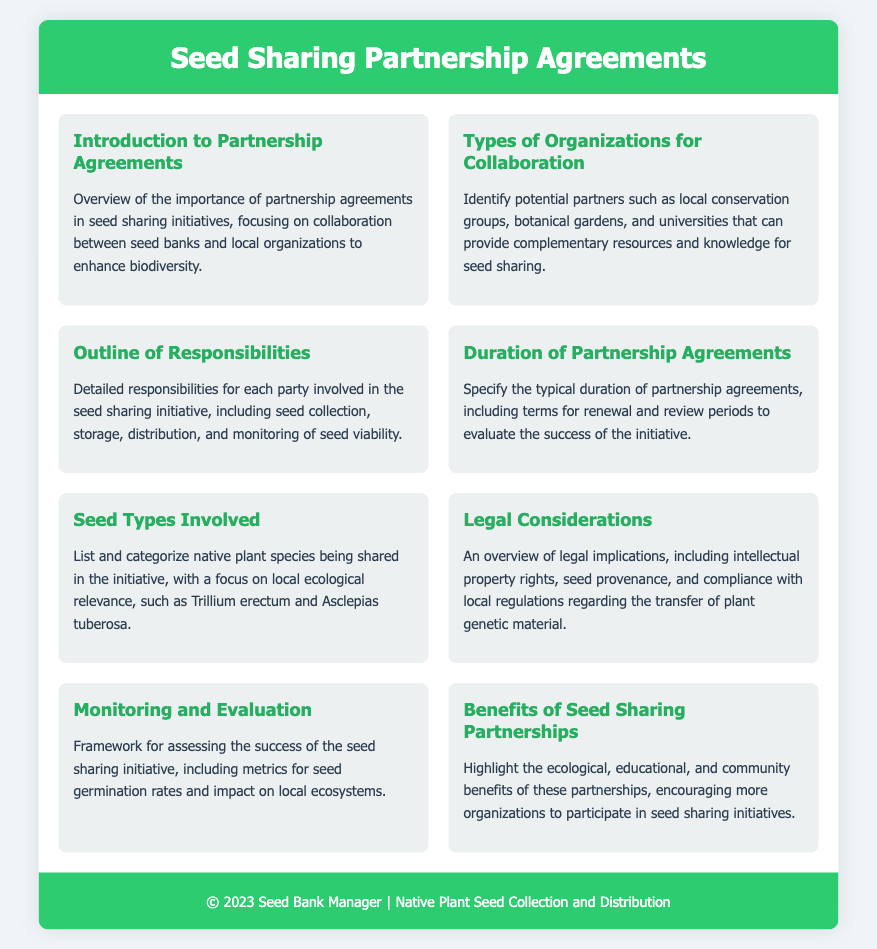what is the title of the document? The title is found in the header section of the document, which states the purpose of the content.
Answer: Seed Sharing Partnership Agreements what type of organizations are identified for collaboration? The section titled "Types of Organizations for Collaboration" lists the potential partners for this initiative.
Answer: Local conservation groups, botanical gardens, and universities what is included in the outline of responsibilities? The "Outline of Responsibilities" section details each party's role in the seed sharing initiative, including several key activities.
Answer: Seed collection, storage, distribution, and monitoring of seed viability how long is the typical duration of partnership agreements? The "Duration of Partnership Agreements" section specifies the length of these agreements, including related terms.
Answer: Typically specified duration which native plant species are mentioned in the seed types involved? The section titled "Seed Types Involved" lists specific plant species relevant to the initiative.
Answer: Trillium erectum and Asclepias tuberosa what legal considerations are highlighted in the document? The "Legal Considerations" section outlines important legal implications relevant to the initiative.
Answer: Intellectual property rights, seed provenance, and compliance with local regulations what metrics are suggested for monitoring and evaluation? Information can be found in the "Monitoring and Evaluation" section, outlining key performance indicators.
Answer: Seed germination rates and impact on local ecosystems what are the benefits of seed sharing partnerships? The section titled "Benefits of Seed Sharing Partnerships" outlines various positive outcomes of these collaborations.
Answer: Ecological, educational, and community benefits 